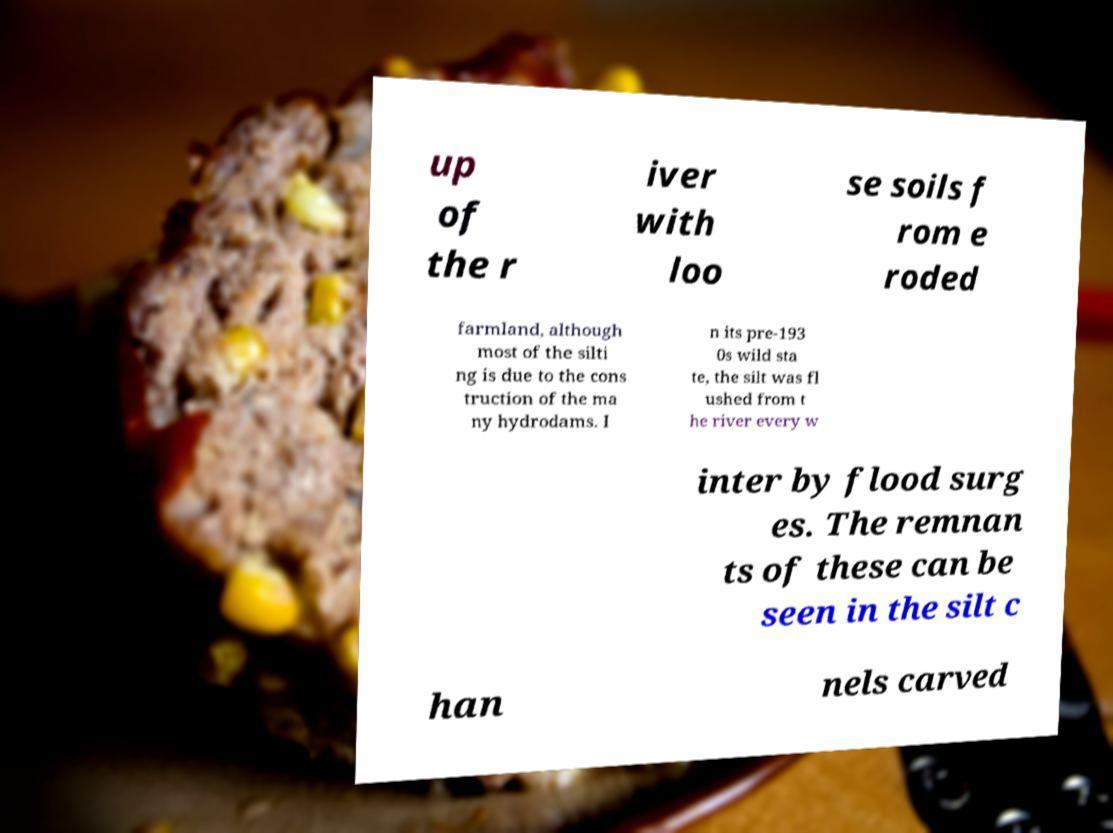I need the written content from this picture converted into text. Can you do that? up of the r iver with loo se soils f rom e roded farmland, although most of the silti ng is due to the cons truction of the ma ny hydrodams. I n its pre-193 0s wild sta te, the silt was fl ushed from t he river every w inter by flood surg es. The remnan ts of these can be seen in the silt c han nels carved 